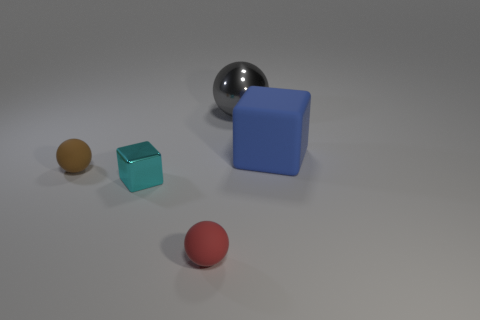Add 2 large metal spheres. How many objects exist? 7 Subtract all big spheres. How many spheres are left? 2 Subtract all brown spheres. How many spheres are left? 2 Subtract 2 balls. How many balls are left? 1 Subtract all balls. How many objects are left? 2 Subtract all large gray shiny cylinders. Subtract all large spheres. How many objects are left? 4 Add 5 brown rubber objects. How many brown rubber objects are left? 6 Add 4 big blue metal cylinders. How many big blue metal cylinders exist? 4 Subtract 1 red spheres. How many objects are left? 4 Subtract all blue balls. Subtract all gray blocks. How many balls are left? 3 